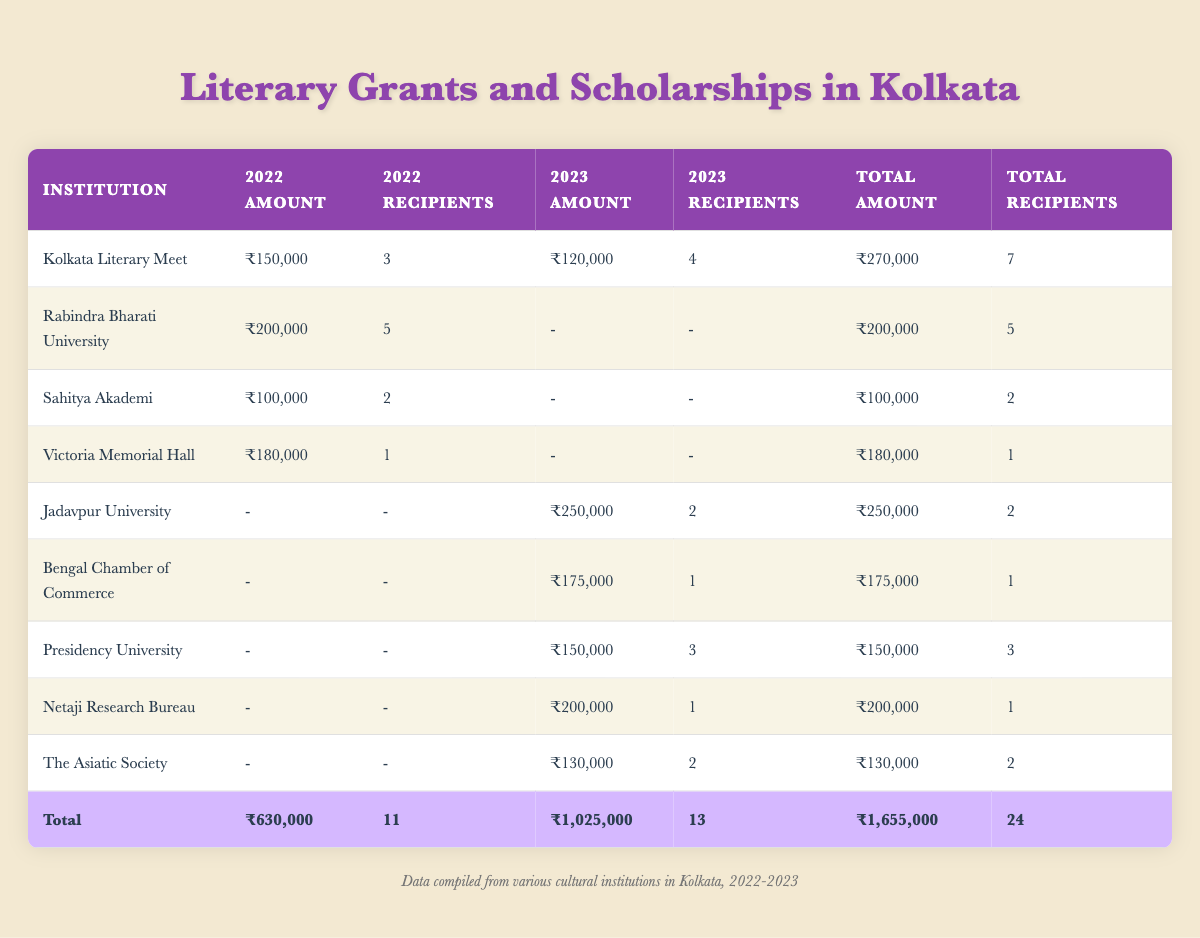What is the total funding allocated by the Kolkata Literary Meet in 2022? The amount allocated by the Kolkata Literary Meet in 2022 is ₹150,000. This value can be found in the row pertaining to the Kolkata Literary Meet under the "2022 Amount" column.
Answer: ₹150,000 How many total recipients received funding from Rabindra Bharati University? Rabindra Bharati University had 5 recipients in 2022, and they didn't have any funding listed for 2023. Therefore, the total number of recipients from Rabindra Bharati University is just 5 (from 2022).
Answer: 5 Which institution provided the most total funding across both years? To find the institution with the most funding, we need to look at the "Total Amount" column. After reviewing the totals, Jadavpur University received ₹250,000 in 2023, and the next highest is the Kolkata Literary Meet with ₹270,000. Thus, the institution with the most total funding is Jadavpur University with ₹250,000.
Answer: Jadavpur University Did any institution receive funding from both private donors and the state government? Yes, the Kolkata Literary Meet received funding from private donors in both 2022 and 2023, while Rabindra Bharati University received funding from the state government in 2022. However, these two institutions didn't overlap in funding sources.
Answer: Yes What is the average amount of funding allocated per recipient for the funding from the Bengal Chamber of Commerce in 2023? The Bengal Chamber of Commerce received ₹175,000 for 1 recipient in 2023. The average amount is calculated by dividing the total funding by the number of recipients: ₹175,000 / 1 = ₹175,000.
Answer: ₹175,000 What was the total funding allocated for translation-related projects in both years? The only translation grant was provided by Sahitya Akademi in 2022 for ₹100,000, and no translation-related grants appeared in 2023. Therefore, the total funding for translation-related projects is just ₹100,000.
Answer: ₹100,000 Which genre received the highest total funding across both years? By reviewing the genres and their total funds, Historical Fiction (from Victoria Memorial Hall in 2022 with ₹180,000) and Bengali Literature (from Presidency University in 2023 with ₹150,000) do not surpass the Literary Criticism (from Jadavpur University in 2023 with ₹250,000). Thus, Literary Criticism received the highest total funding.
Answer: Literary Criticism How many genres received funding in 2022? In 2022, the following genres received funding: Poetry, Fiction, Translation, and Historical Fiction. That totals to 4 distinct genres receiving funding.
Answer: 4 Was there any funding awarded to non-fiction genres in 2022? No funding was awarded to any non-fiction genres in 2022 as per the data provided. The only non-fiction funding in 2023 was the Business Writing Grant from Bengal Chamber of Commerce.
Answer: No 